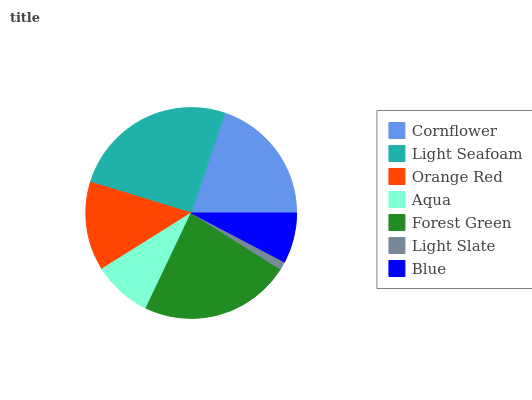Is Light Slate the minimum?
Answer yes or no. Yes. Is Light Seafoam the maximum?
Answer yes or no. Yes. Is Orange Red the minimum?
Answer yes or no. No. Is Orange Red the maximum?
Answer yes or no. No. Is Light Seafoam greater than Orange Red?
Answer yes or no. Yes. Is Orange Red less than Light Seafoam?
Answer yes or no. Yes. Is Orange Red greater than Light Seafoam?
Answer yes or no. No. Is Light Seafoam less than Orange Red?
Answer yes or no. No. Is Orange Red the high median?
Answer yes or no. Yes. Is Orange Red the low median?
Answer yes or no. Yes. Is Forest Green the high median?
Answer yes or no. No. Is Light Seafoam the low median?
Answer yes or no. No. 